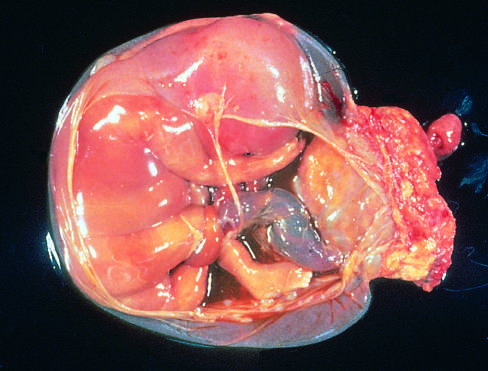s the cause of reversible injury at the right, in the specimen shown?
Answer the question using a single word or phrase. No 